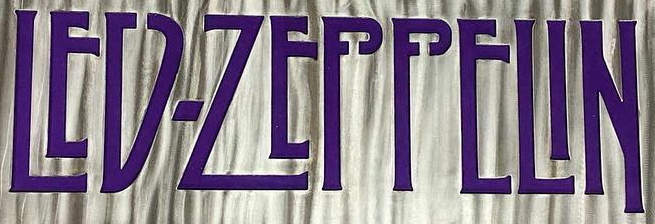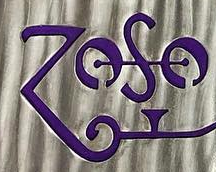Identify the words shown in these images in order, separated by a semicolon. LED-ZEPPELIN; ZOSO 